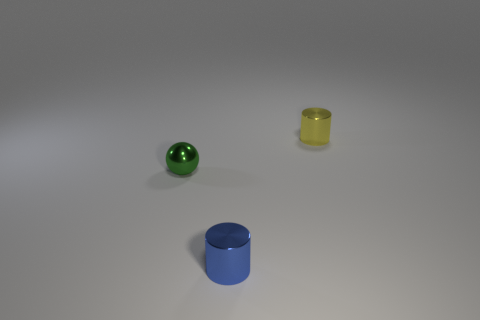Add 2 tiny red metallic objects. How many objects exist? 5 Subtract all cylinders. How many objects are left? 1 Add 2 metallic balls. How many metallic balls are left? 3 Add 1 balls. How many balls exist? 2 Subtract 0 brown cylinders. How many objects are left? 3 Subtract all tiny blue things. Subtract all blue cylinders. How many objects are left? 1 